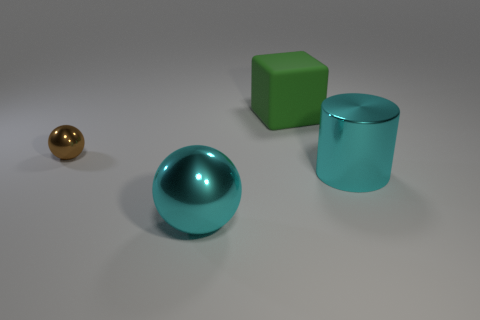Add 2 rubber cubes. How many objects exist? 6 Subtract all cylinders. How many objects are left? 3 Add 2 brown shiny things. How many brown shiny things are left? 3 Add 2 small brown metallic spheres. How many small brown metallic spheres exist? 3 Subtract 1 brown balls. How many objects are left? 3 Subtract all big gray shiny blocks. Subtract all small brown things. How many objects are left? 3 